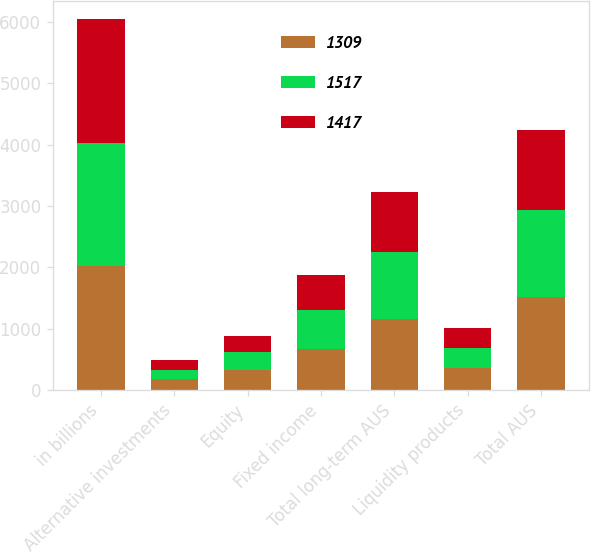Convert chart to OTSL. <chart><loc_0><loc_0><loc_500><loc_500><stacked_bar_chart><ecel><fcel>in billions<fcel>Alternative investments<fcel>Equity<fcel>Fixed income<fcel>Total long-term AUS<fcel>Liquidity products<fcel>Total AUS<nl><fcel>1309<fcel>2018<fcel>171<fcel>329<fcel>665<fcel>1165<fcel>352<fcel>1517<nl><fcel>1517<fcel>2017<fcel>162<fcel>292<fcel>633<fcel>1087<fcel>330<fcel>1417<nl><fcel>1417<fcel>2016<fcel>149<fcel>256<fcel>578<fcel>983<fcel>326<fcel>1309<nl></chart> 